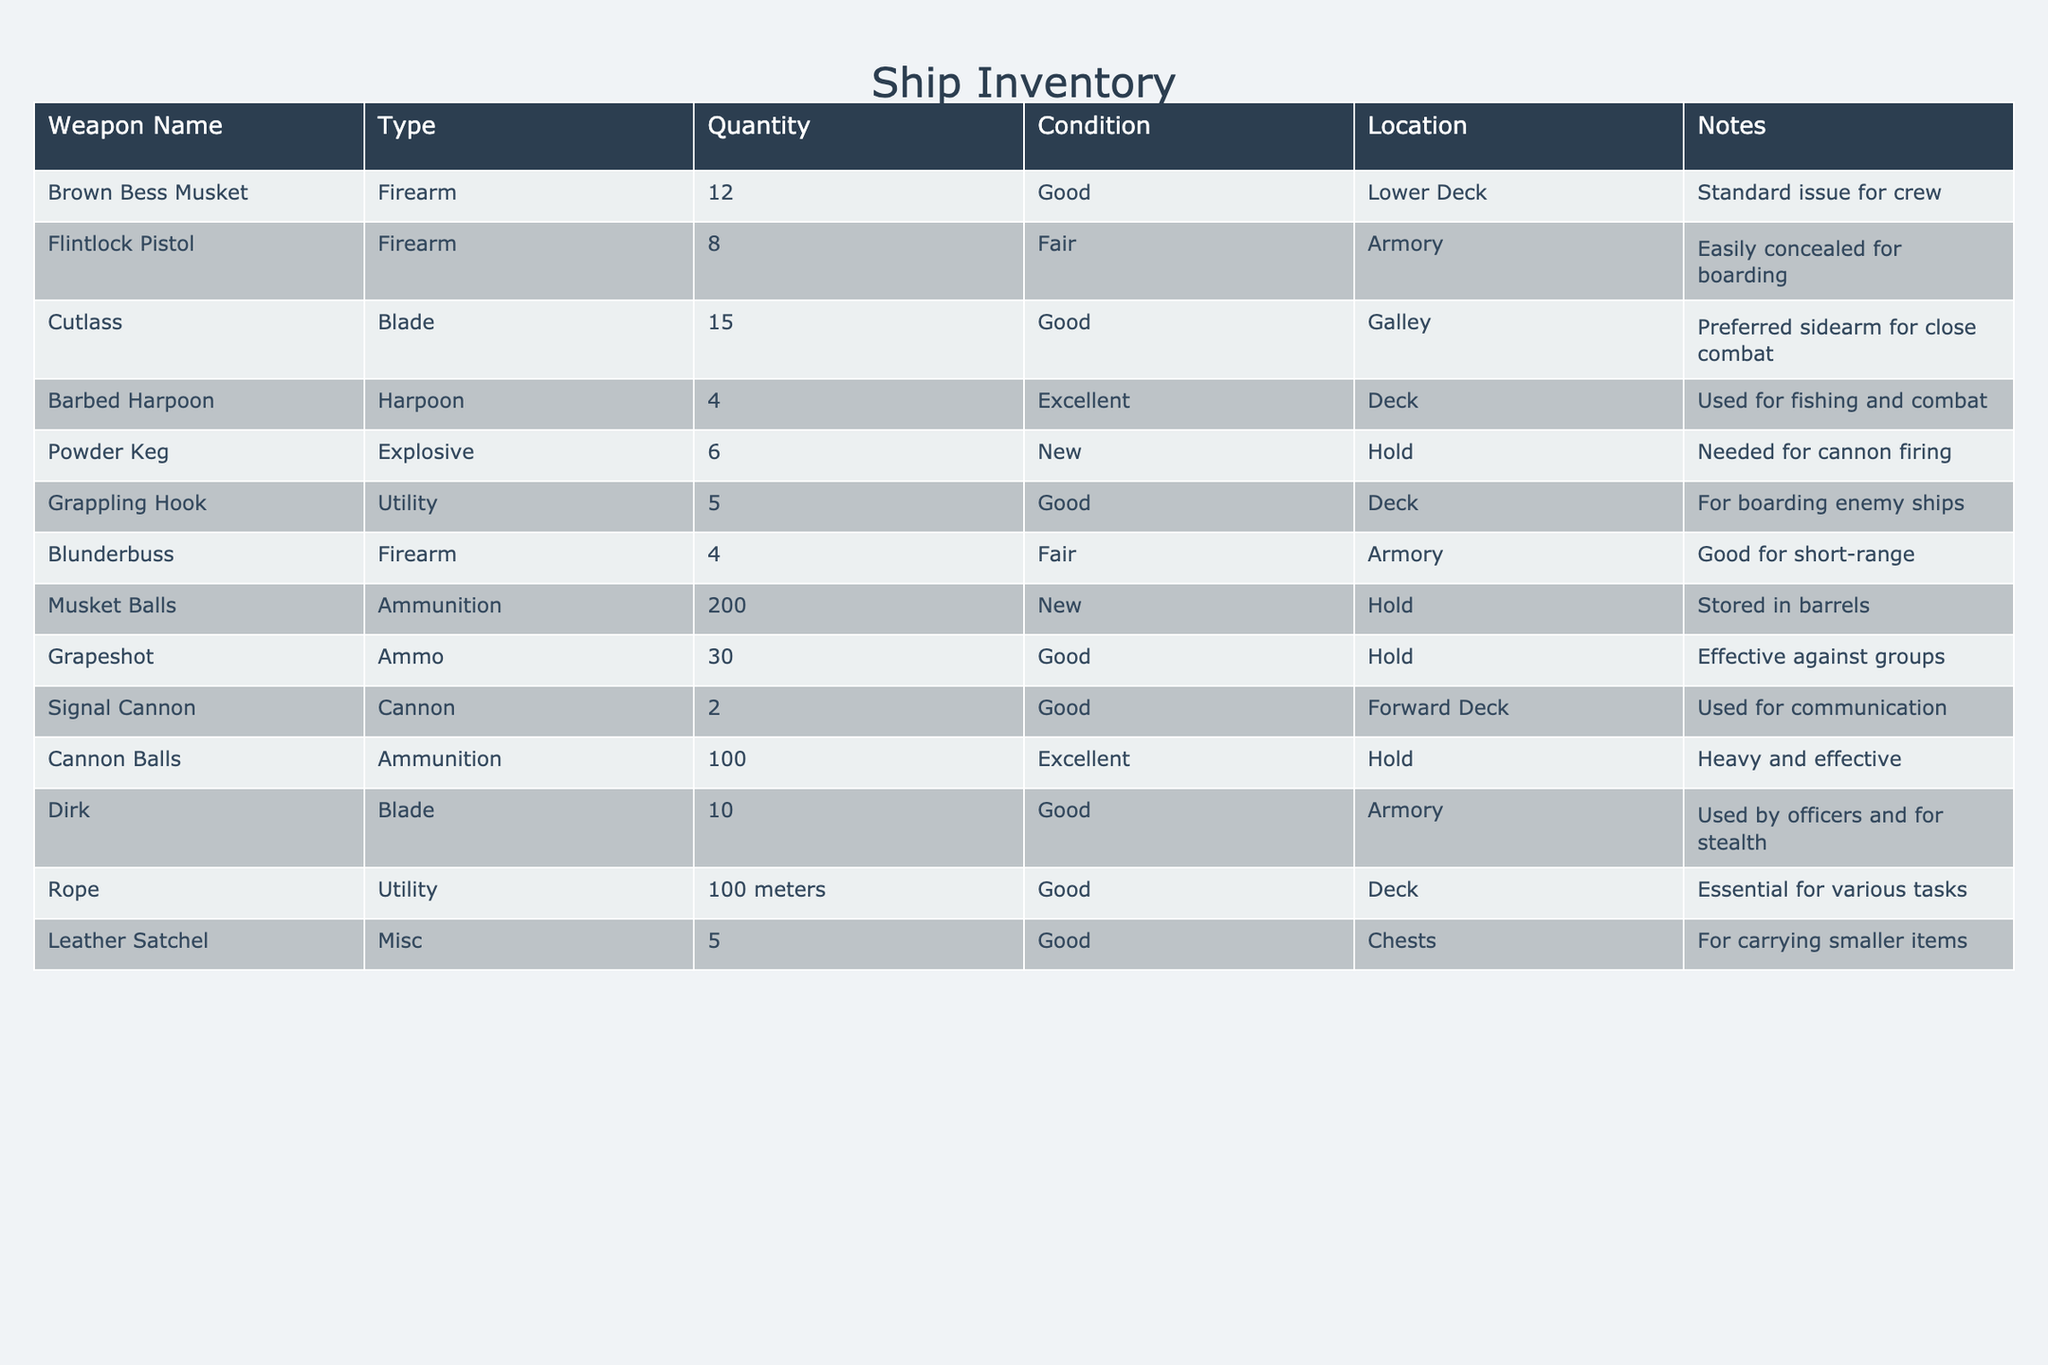What is the total quantity of firearms on board? There are three types of firearms listed: Brown Bess Musket (12), Flintlock Pistol (8), and Blunderbuss (4). Adding these quantities together (12 + 8 + 4) gives a total of 24 firearms on board.
Answer: 24 How many weapons are in good condition? The weapons listed as being in good condition are the Brown Bess Musket (12), Cutlass (15), Grappling Hook (5), Cannon Balls (100), Dirk (10), and Rope (100 meters). Counting these gives a total of 6 items in good condition.
Answer: 6 Is the Powder Keg in new condition? The table states that Powder Keg's condition is listed as new. Hence, the answer to this fact-based question is true.
Answer: Yes Which weapon has the highest quantity on board? Looking through the quantities in the table, the Cutlass has the highest quantity at 15, compared to the other weapons listed. Therefore, the Cutlass is the weapon with the highest quantity on board.
Answer: Cutlass What is the sum of all types of ammunition available? The ammunition types listed are Musket Balls (200), Grapeshot (30), and Cannon Balls (100). Adding these together (200 + 30 + 100) results in a total ammunition quantity of 330.
Answer: 330 How many more Cutlasses are there than Flintlock Pistols? The table shows 15 Cutlasses and 8 Flintlock Pistols. To find out how many more Cutlasses there are, subtract the quantity of Flintlock Pistols from that of Cutlasses: 15 - 8 = 7.
Answer: 7 Are there any weapons specifically used for stealth? The Dirk is noted as being used by officers and for stealth. Thus, the answer to whether there are stealth weapons on board is true.
Answer: Yes What is the average quantity of the utility items on board? There are two utility items listed: Grappling Hook (5) and Rope (100 meters). To find the average, we first sum the quantities (5 + 100) = 105. Then, we divide by the number of utility items (2): 105 / 2 = 52.5.
Answer: 52.5 